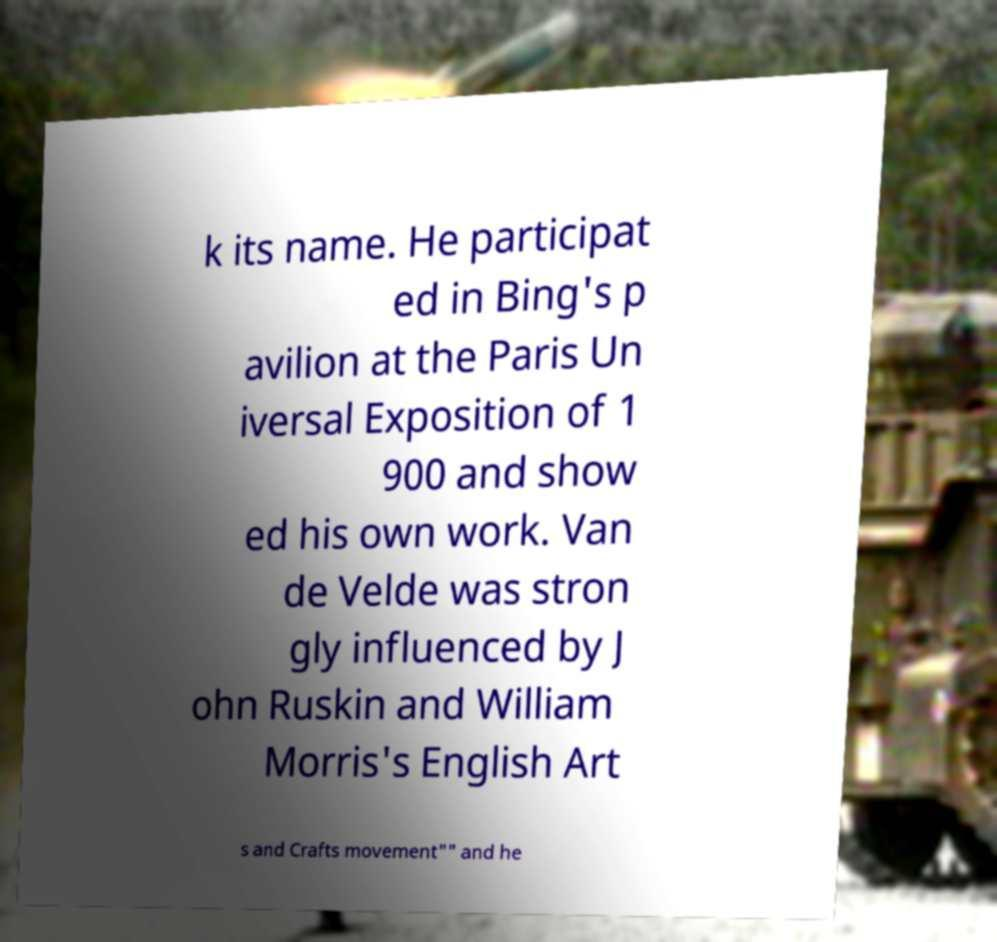What messages or text are displayed in this image? I need them in a readable, typed format. k its name. He participat ed in Bing's p avilion at the Paris Un iversal Exposition of 1 900 and show ed his own work. Van de Velde was stron gly influenced by J ohn Ruskin and William Morris's English Art s and Crafts movement"" and he 